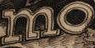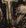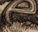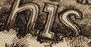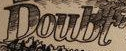Read the text content from these images in order, separated by a semicolon. mo; #; e; his; Doubt 